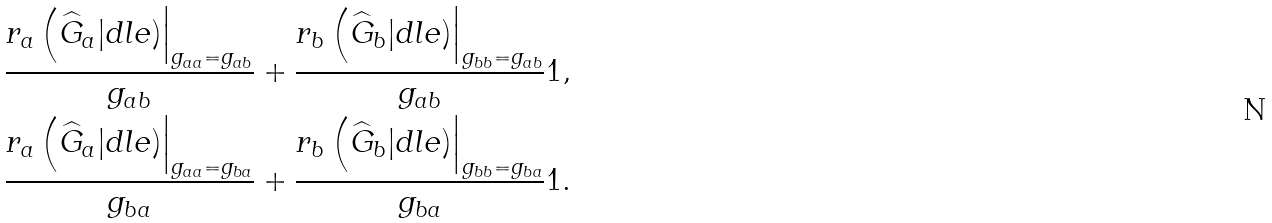<formula> <loc_0><loc_0><loc_500><loc_500>\frac { r _ { a } \left ( \widehat { G } _ { a } | d l e ) \right | _ { g _ { a a } = g _ { a b } } } { g _ { a b } } + \frac { r _ { b } \left ( \widehat { G } _ { b } | d l e ) \right | _ { g _ { b b } = g _ { a b } } } { g _ { a b } } & 1 , \\ \frac { r _ { a } \left ( \widehat { G } _ { a } | d l e ) \right | _ { g _ { a a } = g _ { b a } } } { g _ { b a } } + \frac { r _ { b } \left ( \widehat { G } _ { b } | d l e ) \right | _ { g _ { b b } = g _ { b a } } } { g _ { b a } } & 1 .</formula> 